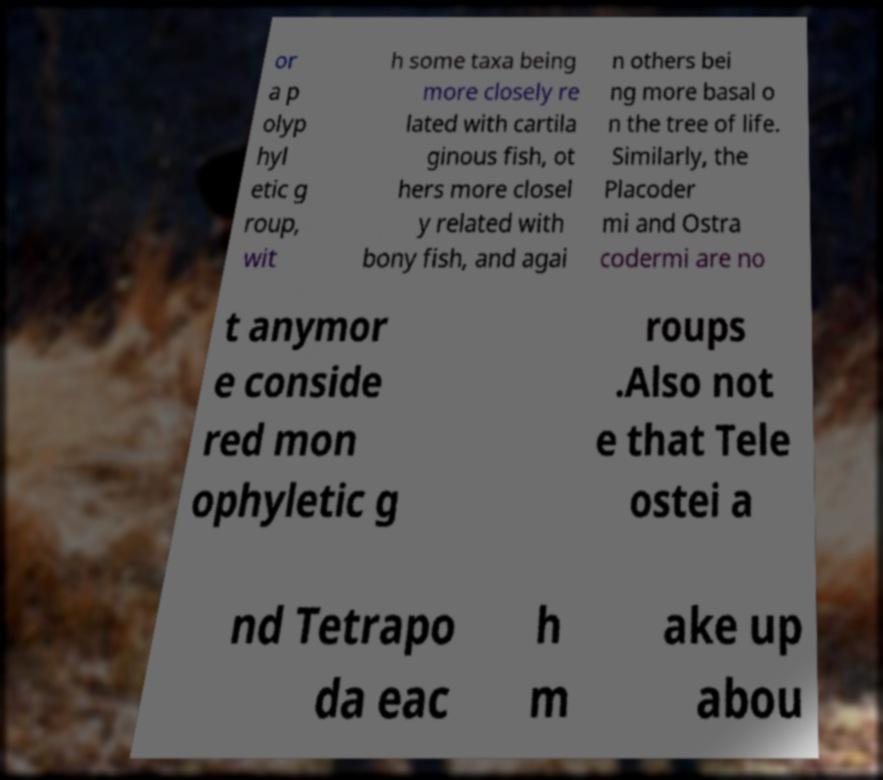What messages or text are displayed in this image? I need them in a readable, typed format. or a p olyp hyl etic g roup, wit h some taxa being more closely re lated with cartila ginous fish, ot hers more closel y related with bony fish, and agai n others bei ng more basal o n the tree of life. Similarly, the Placoder mi and Ostra codermi are no t anymor e conside red mon ophyletic g roups .Also not e that Tele ostei a nd Tetrapo da eac h m ake up abou 